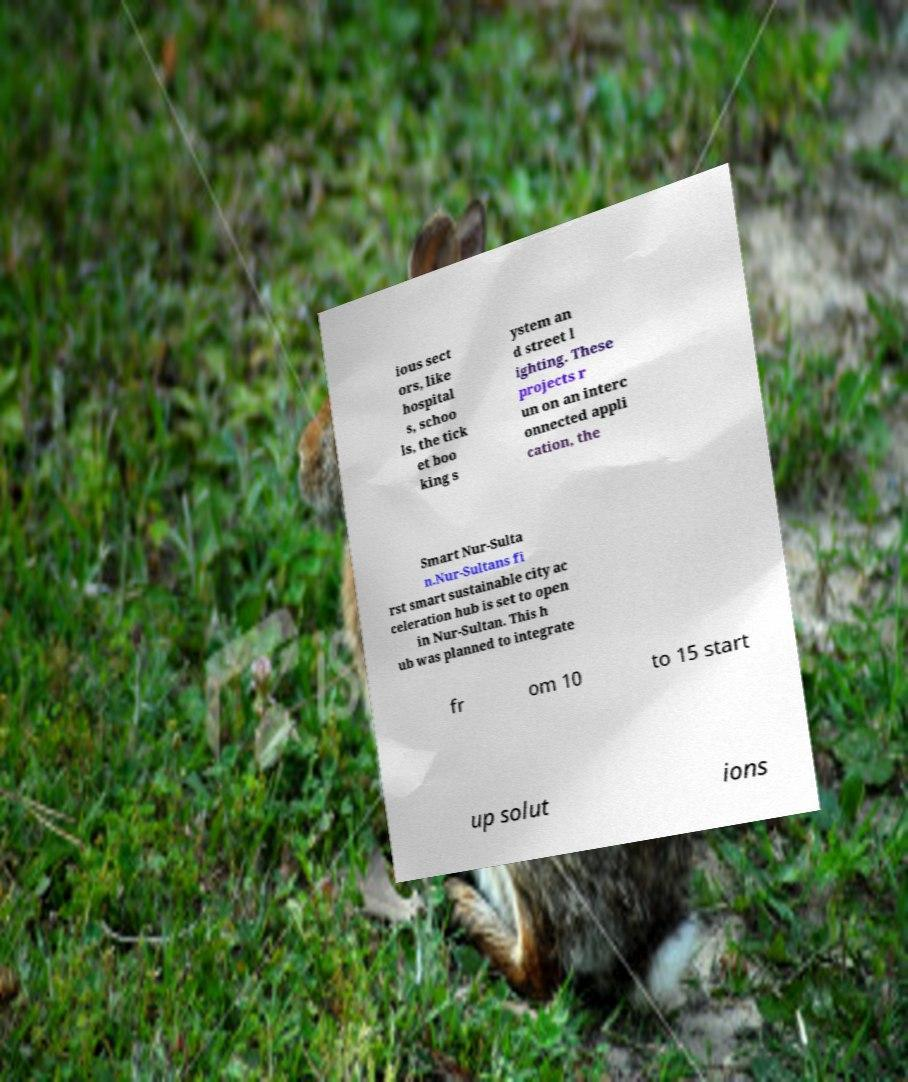Could you extract and type out the text from this image? ious sect ors, like hospital s, schoo ls, the tick et boo king s ystem an d street l ighting. These projects r un on an interc onnected appli cation, the Smart Nur-Sulta n.Nur-Sultans fi rst smart sustainable city ac celeration hub is set to open in Nur-Sultan. This h ub was planned to integrate fr om 10 to 15 start up solut ions 